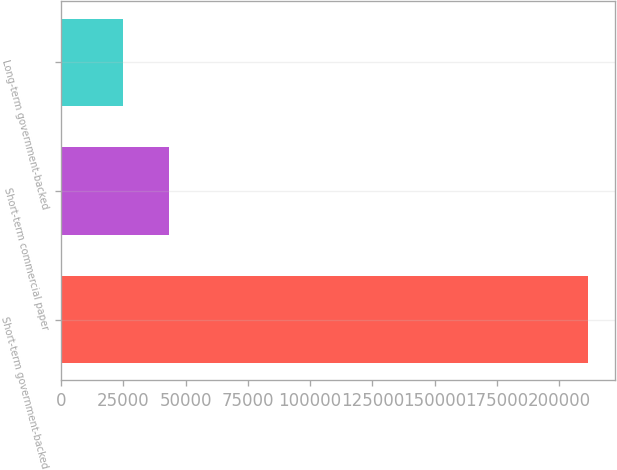Convert chart. <chart><loc_0><loc_0><loc_500><loc_500><bar_chart><fcel>Short-term government-backed<fcel>Short-term commercial paper<fcel>Long-term government-backed<nl><fcel>211720<fcel>43480.3<fcel>24787<nl></chart> 